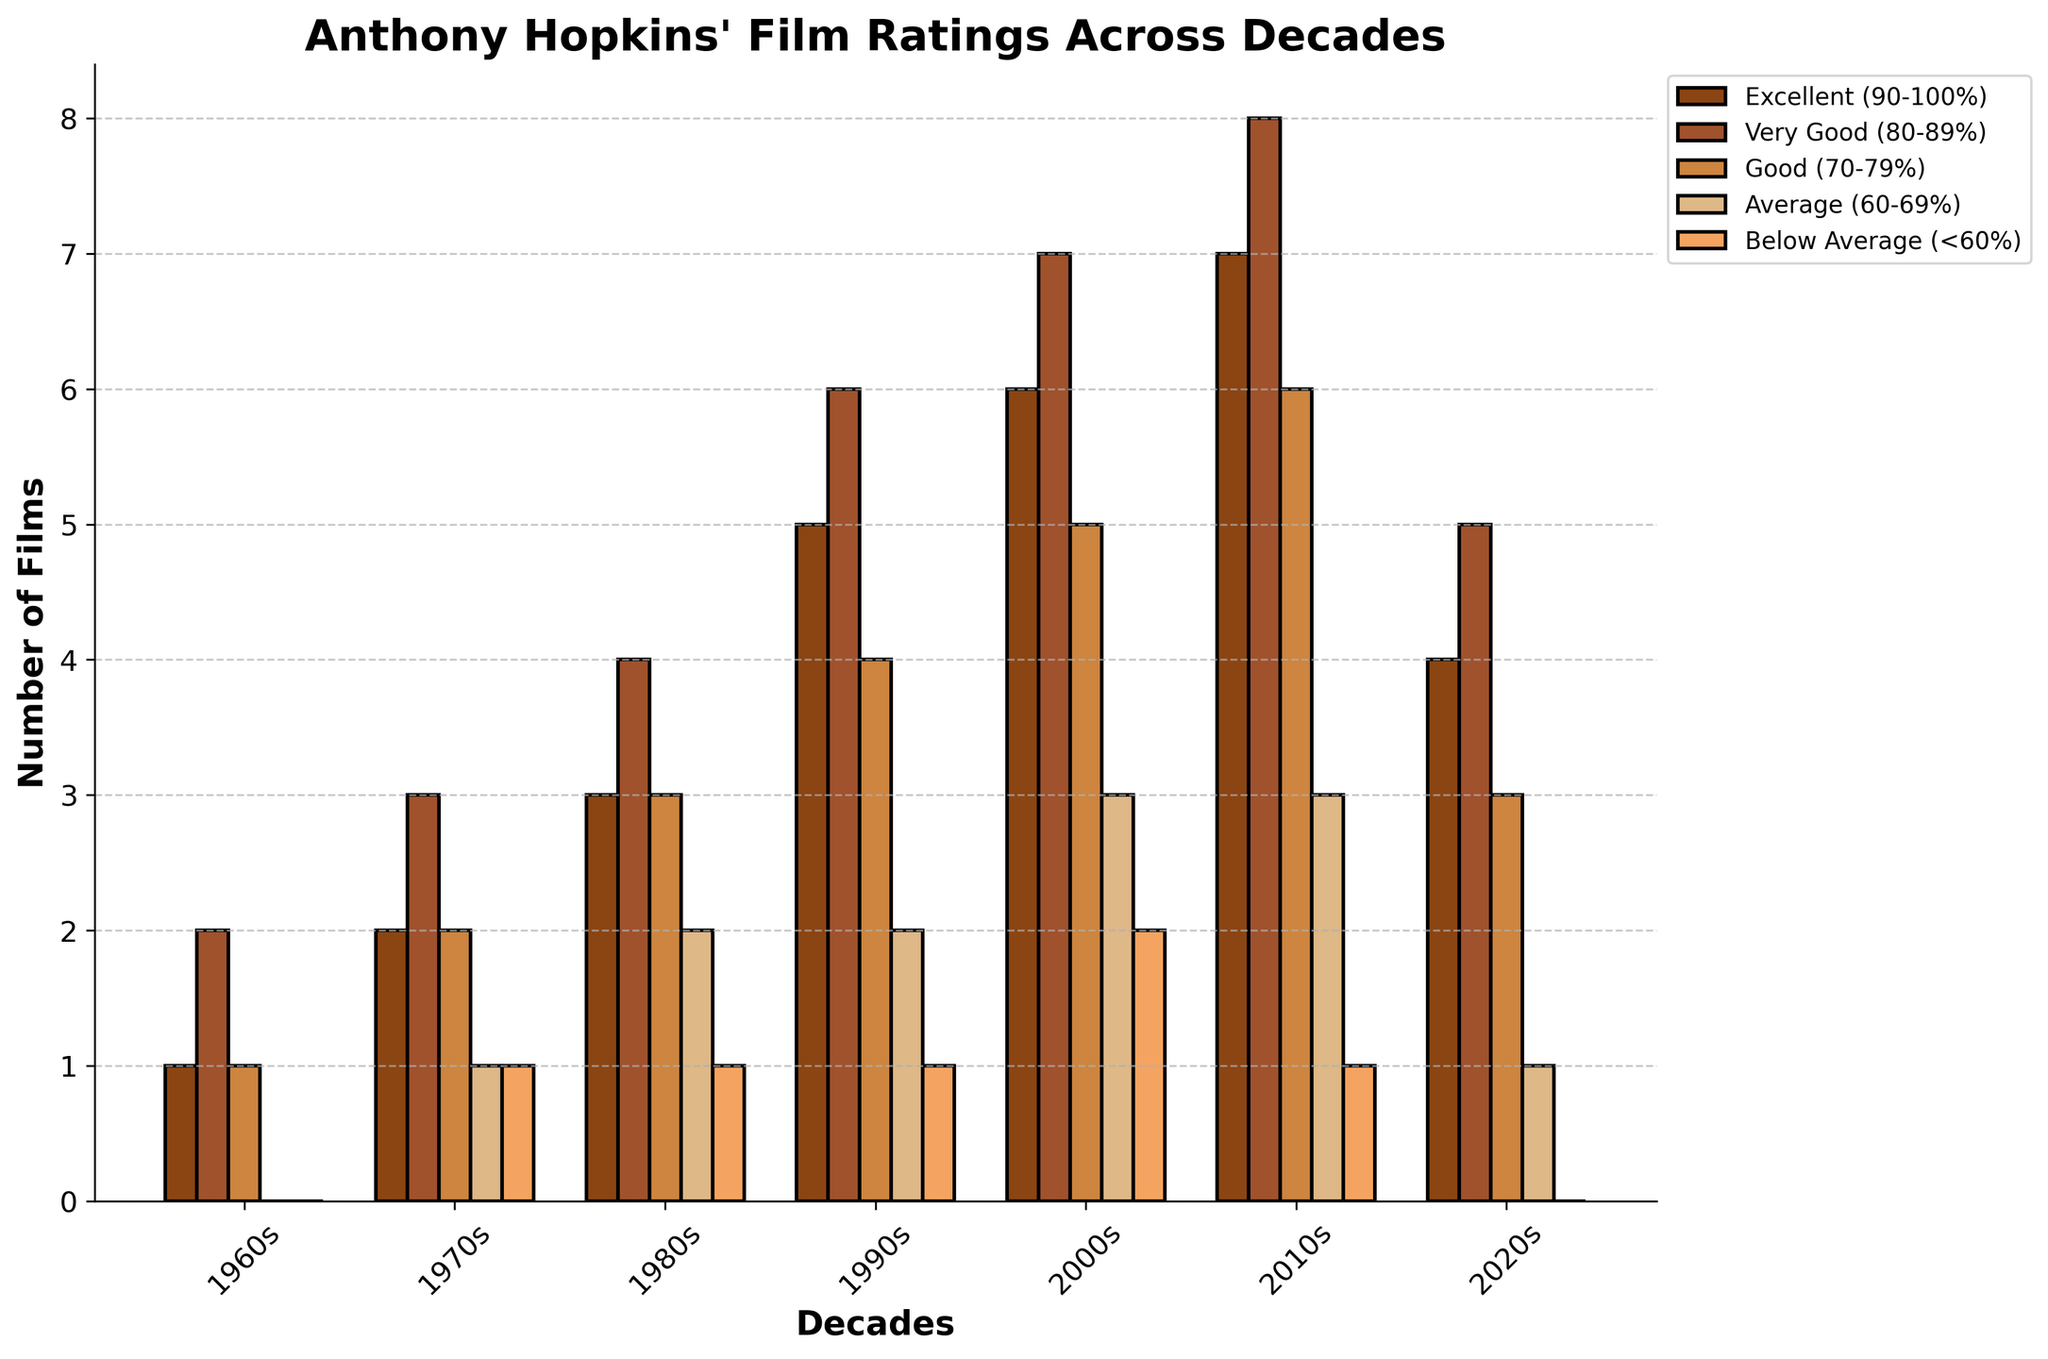Which decade has the most films rated as "Excellent (90-100%)"? The highest bar in the "Excellent (90-100%)" category is seen in the 2010s.
Answer: 2010s How many total films in the 2000s fall into the "Average (60-69%)" and "Below Average (<60%)" categories? The number of films in the "Average (60-69%)" category in the 2000s is 3, and in the "Below Average (<60%)" category is 2, so the total is 3 + 2.
Answer: 5 Compare the total number of "Very Good (80-89%)" films between the 1980s and the 2020s. Which decade has more? The number of "Very Good (80-89%)" films in the 1980s is 4, and in the 2020s it is 5. Therefore, the 2020s have more.
Answer: 2020s Which decade shows the least number of "Below Average (<60%)" films? The decades with no "Below Average (<60%)" films are the 1960s and the 2020s. Both have an equal and least number.
Answer: 1960s and 2020s What is the combined total of "Excellent (90-100%)" and "Good (70-79%)" films in the 1990s? The total number of "Excellent (90-100%)" films in the 1990s is 5, and the number of "Good (70-79%)" films in the 1990s is 4, so the combined total is 5 + 4.
Answer: 9 In which decade did Anthony Hopkins have the most "Good (70-79%)" rated films? The highest bar in the "Good (70-79%)" category is seen in the 2010s.
Answer: 2010s How does the total number of "Excellent (90-100%)" rated films in the 1970s compare to the 1960s? The number of "Excellent (90-100%)" films in the 1970s is 2, while in the 1960s it is 1. Therefore, the 1970s have 1 more.
Answer: 1970s have 1 more Between which two decades is the increase in the number of "Excellent (90-100%)" films the greatest? The increase from the 1960s to the 1970s is 1, from the 1970s to the 1980s is 1, from the 1980s to the 1990s is 2, from the 1990s to the 2000s is 1, from the 2000s to the 2010s is 1, and from the 2010s to the 2020s is a decrease of 3. Therefore, the greatest increase is from the 1980s to the 1990s.
Answer: 1980s to 1990s 